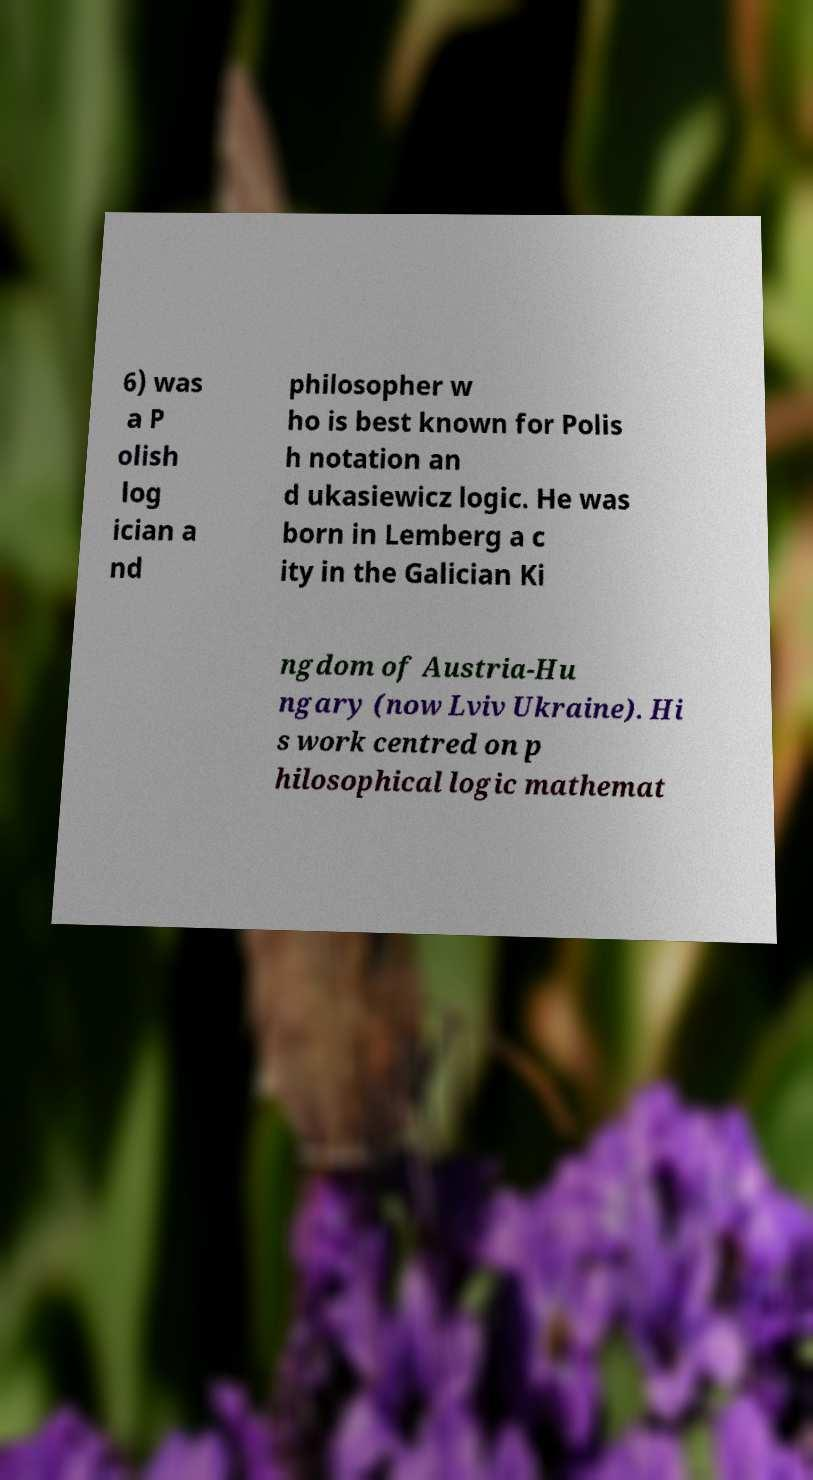Can you accurately transcribe the text from the provided image for me? 6) was a P olish log ician a nd philosopher w ho is best known for Polis h notation an d ukasiewicz logic. He was born in Lemberg a c ity in the Galician Ki ngdom of Austria-Hu ngary (now Lviv Ukraine). Hi s work centred on p hilosophical logic mathemat 